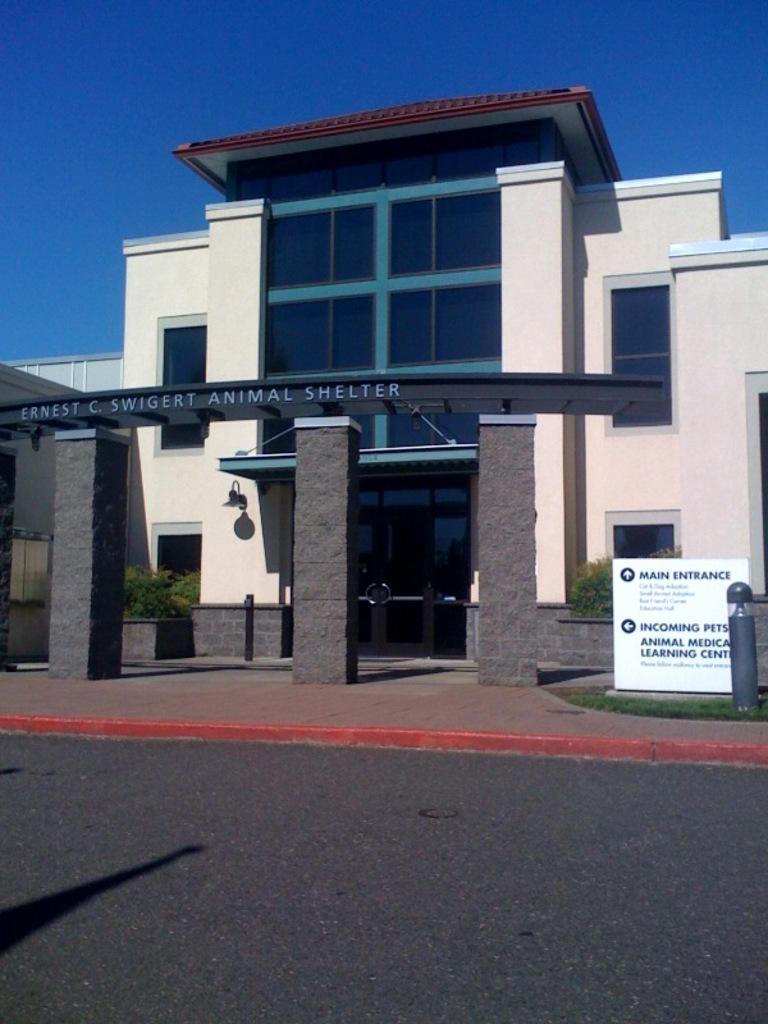Describe this image in one or two sentences. This is a building with the glass doors and building. I can see a name board, which is on the pillars. This is the lamp, which is attached to a building wall. I can see the bushes. This is a board. On the right side of the image, I can see a pole. I think this is the road. Here is the sky, which is blue in color. 